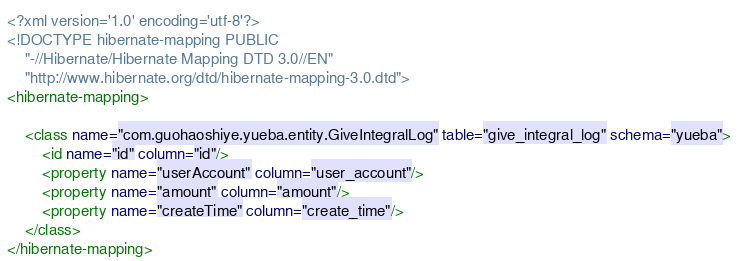Convert code to text. <code><loc_0><loc_0><loc_500><loc_500><_XML_><?xml version='1.0' encoding='utf-8'?>
<!DOCTYPE hibernate-mapping PUBLIC
    "-//Hibernate/Hibernate Mapping DTD 3.0//EN"
    "http://www.hibernate.org/dtd/hibernate-mapping-3.0.dtd">
<hibernate-mapping>

    <class name="com.guohaoshiye.yueba.entity.GiveIntegralLog" table="give_integral_log" schema="yueba">
        <id name="id" column="id"/>
        <property name="userAccount" column="user_account"/>
        <property name="amount" column="amount"/>
        <property name="createTime" column="create_time"/>
    </class>
</hibernate-mapping></code> 